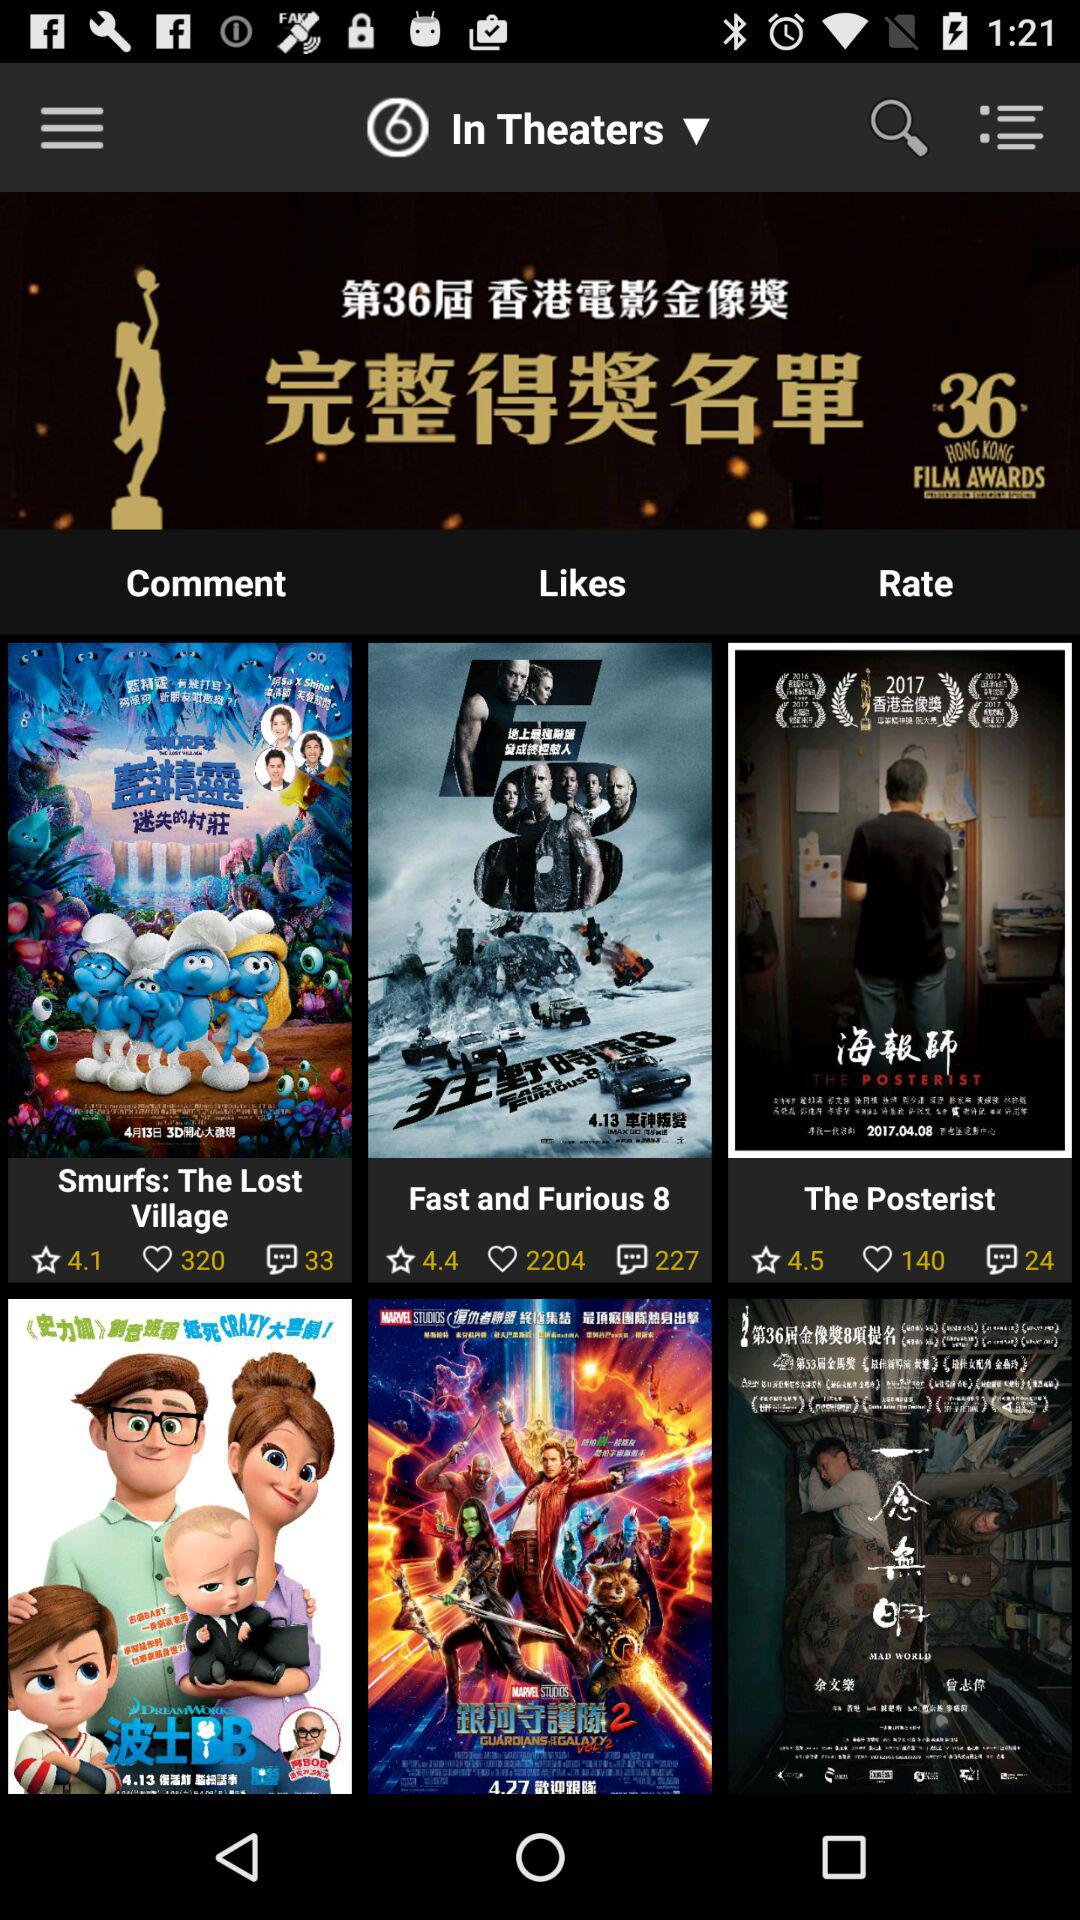What is the rating of "The Posterist"? The rating is 4.5. 